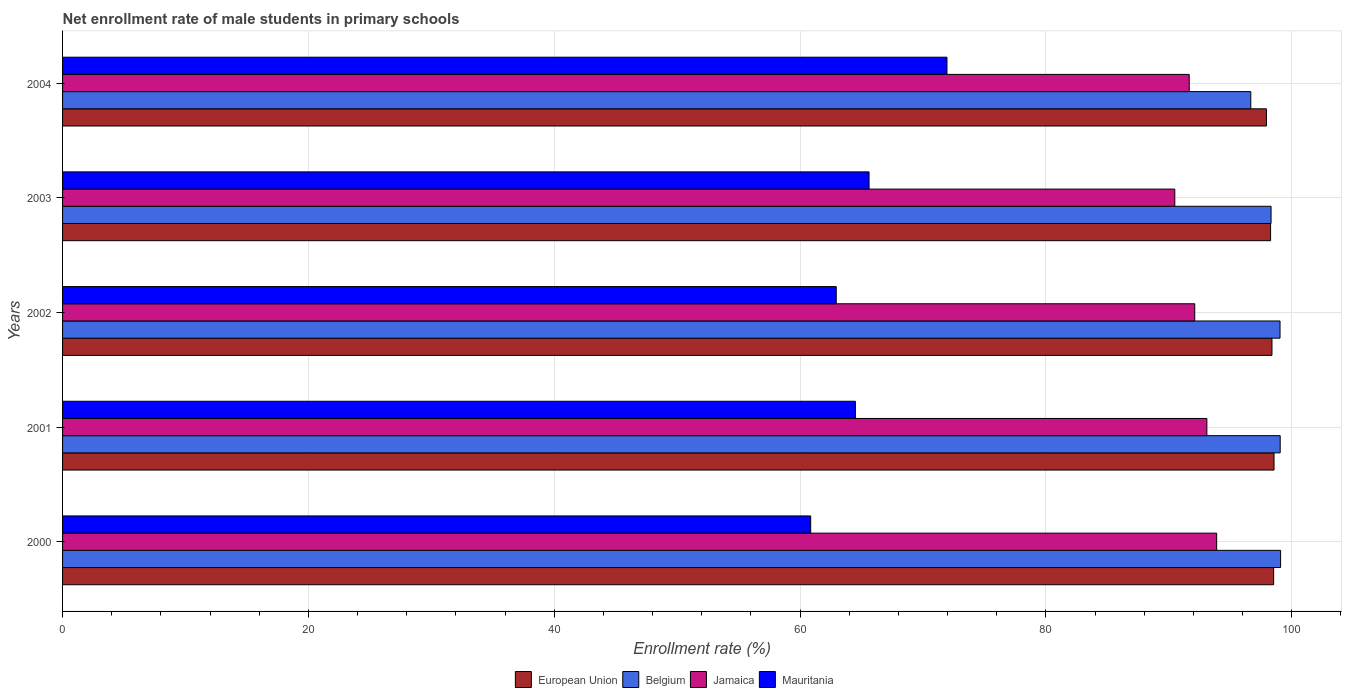How many different coloured bars are there?
Your answer should be very brief. 4. How many groups of bars are there?
Offer a very short reply. 5. Are the number of bars on each tick of the Y-axis equal?
Offer a very short reply. Yes. In how many cases, is the number of bars for a given year not equal to the number of legend labels?
Ensure brevity in your answer.  0. What is the net enrollment rate of male students in primary schools in Jamaica in 2003?
Your response must be concise. 90.48. Across all years, what is the maximum net enrollment rate of male students in primary schools in Mauritania?
Provide a succinct answer. 71.95. Across all years, what is the minimum net enrollment rate of male students in primary schools in Mauritania?
Offer a very short reply. 60.86. In which year was the net enrollment rate of male students in primary schools in European Union maximum?
Make the answer very short. 2001. In which year was the net enrollment rate of male students in primary schools in Mauritania minimum?
Offer a terse response. 2000. What is the total net enrollment rate of male students in primary schools in European Union in the graph?
Your response must be concise. 491.68. What is the difference between the net enrollment rate of male students in primary schools in European Union in 2000 and that in 2001?
Provide a succinct answer. -0.03. What is the difference between the net enrollment rate of male students in primary schools in Belgium in 2004 and the net enrollment rate of male students in primary schools in Jamaica in 2002?
Make the answer very short. 4.56. What is the average net enrollment rate of male students in primary schools in European Union per year?
Make the answer very short. 98.34. In the year 2000, what is the difference between the net enrollment rate of male students in primary schools in Mauritania and net enrollment rate of male students in primary schools in European Union?
Keep it short and to the point. -37.66. What is the ratio of the net enrollment rate of male students in primary schools in Jamaica in 2000 to that in 2003?
Give a very brief answer. 1.04. What is the difference between the highest and the second highest net enrollment rate of male students in primary schools in Mauritania?
Ensure brevity in your answer.  6.34. What is the difference between the highest and the lowest net enrollment rate of male students in primary schools in Belgium?
Keep it short and to the point. 2.42. Is the sum of the net enrollment rate of male students in primary schools in European Union in 2001 and 2003 greater than the maximum net enrollment rate of male students in primary schools in Belgium across all years?
Keep it short and to the point. Yes. What does the 3rd bar from the top in 2002 represents?
Offer a terse response. Belgium. What does the 3rd bar from the bottom in 2000 represents?
Your answer should be compact. Jamaica. How many years are there in the graph?
Keep it short and to the point. 5. What is the difference between two consecutive major ticks on the X-axis?
Give a very brief answer. 20. Are the values on the major ticks of X-axis written in scientific E-notation?
Offer a very short reply. No. Does the graph contain any zero values?
Provide a short and direct response. No. Where does the legend appear in the graph?
Offer a terse response. Bottom center. How are the legend labels stacked?
Your answer should be very brief. Horizontal. What is the title of the graph?
Keep it short and to the point. Net enrollment rate of male students in primary schools. Does "Russian Federation" appear as one of the legend labels in the graph?
Offer a terse response. No. What is the label or title of the X-axis?
Provide a succinct answer. Enrollment rate (%). What is the label or title of the Y-axis?
Your answer should be compact. Years. What is the Enrollment rate (%) in European Union in 2000?
Your answer should be very brief. 98.53. What is the Enrollment rate (%) in Belgium in 2000?
Offer a terse response. 99.09. What is the Enrollment rate (%) of Jamaica in 2000?
Provide a short and direct response. 93.89. What is the Enrollment rate (%) in Mauritania in 2000?
Offer a terse response. 60.86. What is the Enrollment rate (%) in European Union in 2001?
Your response must be concise. 98.56. What is the Enrollment rate (%) of Belgium in 2001?
Ensure brevity in your answer.  99.06. What is the Enrollment rate (%) in Jamaica in 2001?
Provide a succinct answer. 93.09. What is the Enrollment rate (%) in Mauritania in 2001?
Give a very brief answer. 64.5. What is the Enrollment rate (%) in European Union in 2002?
Make the answer very short. 98.39. What is the Enrollment rate (%) of Belgium in 2002?
Offer a terse response. 99.04. What is the Enrollment rate (%) in Jamaica in 2002?
Your answer should be very brief. 92.11. What is the Enrollment rate (%) in Mauritania in 2002?
Provide a short and direct response. 62.94. What is the Enrollment rate (%) of European Union in 2003?
Offer a terse response. 98.28. What is the Enrollment rate (%) in Belgium in 2003?
Give a very brief answer. 98.32. What is the Enrollment rate (%) in Jamaica in 2003?
Your answer should be compact. 90.48. What is the Enrollment rate (%) of Mauritania in 2003?
Provide a succinct answer. 65.61. What is the Enrollment rate (%) in European Union in 2004?
Give a very brief answer. 97.94. What is the Enrollment rate (%) of Belgium in 2004?
Keep it short and to the point. 96.67. What is the Enrollment rate (%) in Jamaica in 2004?
Give a very brief answer. 91.66. What is the Enrollment rate (%) of Mauritania in 2004?
Give a very brief answer. 71.95. Across all years, what is the maximum Enrollment rate (%) of European Union?
Offer a very short reply. 98.56. Across all years, what is the maximum Enrollment rate (%) in Belgium?
Provide a succinct answer. 99.09. Across all years, what is the maximum Enrollment rate (%) of Jamaica?
Give a very brief answer. 93.89. Across all years, what is the maximum Enrollment rate (%) of Mauritania?
Give a very brief answer. 71.95. Across all years, what is the minimum Enrollment rate (%) of European Union?
Give a very brief answer. 97.94. Across all years, what is the minimum Enrollment rate (%) in Belgium?
Give a very brief answer. 96.67. Across all years, what is the minimum Enrollment rate (%) of Jamaica?
Ensure brevity in your answer.  90.48. Across all years, what is the minimum Enrollment rate (%) in Mauritania?
Provide a succinct answer. 60.86. What is the total Enrollment rate (%) of European Union in the graph?
Offer a very short reply. 491.68. What is the total Enrollment rate (%) of Belgium in the graph?
Offer a terse response. 492.17. What is the total Enrollment rate (%) of Jamaica in the graph?
Provide a succinct answer. 461.23. What is the total Enrollment rate (%) in Mauritania in the graph?
Offer a very short reply. 325.86. What is the difference between the Enrollment rate (%) in European Union in 2000 and that in 2001?
Give a very brief answer. -0.03. What is the difference between the Enrollment rate (%) of Jamaica in 2000 and that in 2001?
Offer a terse response. 0.8. What is the difference between the Enrollment rate (%) in Mauritania in 2000 and that in 2001?
Your answer should be very brief. -3.64. What is the difference between the Enrollment rate (%) in European Union in 2000 and that in 2002?
Your response must be concise. 0.14. What is the difference between the Enrollment rate (%) in Belgium in 2000 and that in 2002?
Provide a succinct answer. 0.05. What is the difference between the Enrollment rate (%) in Jamaica in 2000 and that in 2002?
Give a very brief answer. 1.78. What is the difference between the Enrollment rate (%) of Mauritania in 2000 and that in 2002?
Your answer should be compact. -2.08. What is the difference between the Enrollment rate (%) of European Union in 2000 and that in 2003?
Provide a succinct answer. 0.25. What is the difference between the Enrollment rate (%) of Belgium in 2000 and that in 2003?
Offer a very short reply. 0.78. What is the difference between the Enrollment rate (%) of Jamaica in 2000 and that in 2003?
Ensure brevity in your answer.  3.41. What is the difference between the Enrollment rate (%) in Mauritania in 2000 and that in 2003?
Ensure brevity in your answer.  -4.75. What is the difference between the Enrollment rate (%) of European Union in 2000 and that in 2004?
Your response must be concise. 0.59. What is the difference between the Enrollment rate (%) in Belgium in 2000 and that in 2004?
Offer a very short reply. 2.42. What is the difference between the Enrollment rate (%) of Jamaica in 2000 and that in 2004?
Your answer should be compact. 2.23. What is the difference between the Enrollment rate (%) in Mauritania in 2000 and that in 2004?
Offer a very short reply. -11.09. What is the difference between the Enrollment rate (%) in European Union in 2001 and that in 2002?
Give a very brief answer. 0.17. What is the difference between the Enrollment rate (%) of Belgium in 2001 and that in 2002?
Offer a terse response. 0.01. What is the difference between the Enrollment rate (%) in Jamaica in 2001 and that in 2002?
Give a very brief answer. 0.99. What is the difference between the Enrollment rate (%) of Mauritania in 2001 and that in 2002?
Offer a terse response. 1.56. What is the difference between the Enrollment rate (%) in European Union in 2001 and that in 2003?
Ensure brevity in your answer.  0.28. What is the difference between the Enrollment rate (%) of Belgium in 2001 and that in 2003?
Provide a succinct answer. 0.74. What is the difference between the Enrollment rate (%) in Jamaica in 2001 and that in 2003?
Provide a succinct answer. 2.61. What is the difference between the Enrollment rate (%) in Mauritania in 2001 and that in 2003?
Provide a succinct answer. -1.11. What is the difference between the Enrollment rate (%) in European Union in 2001 and that in 2004?
Give a very brief answer. 0.62. What is the difference between the Enrollment rate (%) in Belgium in 2001 and that in 2004?
Keep it short and to the point. 2.39. What is the difference between the Enrollment rate (%) in Jamaica in 2001 and that in 2004?
Your answer should be very brief. 1.43. What is the difference between the Enrollment rate (%) in Mauritania in 2001 and that in 2004?
Keep it short and to the point. -7.45. What is the difference between the Enrollment rate (%) of European Union in 2002 and that in 2003?
Give a very brief answer. 0.11. What is the difference between the Enrollment rate (%) in Belgium in 2002 and that in 2003?
Your answer should be very brief. 0.73. What is the difference between the Enrollment rate (%) of Jamaica in 2002 and that in 2003?
Offer a terse response. 1.62. What is the difference between the Enrollment rate (%) of Mauritania in 2002 and that in 2003?
Your response must be concise. -2.67. What is the difference between the Enrollment rate (%) in European Union in 2002 and that in 2004?
Your answer should be very brief. 0.45. What is the difference between the Enrollment rate (%) of Belgium in 2002 and that in 2004?
Your response must be concise. 2.38. What is the difference between the Enrollment rate (%) in Jamaica in 2002 and that in 2004?
Give a very brief answer. 0.45. What is the difference between the Enrollment rate (%) of Mauritania in 2002 and that in 2004?
Your answer should be compact. -9.01. What is the difference between the Enrollment rate (%) of European Union in 2003 and that in 2004?
Offer a terse response. 0.34. What is the difference between the Enrollment rate (%) in Belgium in 2003 and that in 2004?
Offer a terse response. 1.65. What is the difference between the Enrollment rate (%) in Jamaica in 2003 and that in 2004?
Your answer should be very brief. -1.17. What is the difference between the Enrollment rate (%) of Mauritania in 2003 and that in 2004?
Provide a succinct answer. -6.34. What is the difference between the Enrollment rate (%) of European Union in 2000 and the Enrollment rate (%) of Belgium in 2001?
Give a very brief answer. -0.53. What is the difference between the Enrollment rate (%) of European Union in 2000 and the Enrollment rate (%) of Jamaica in 2001?
Keep it short and to the point. 5.43. What is the difference between the Enrollment rate (%) of European Union in 2000 and the Enrollment rate (%) of Mauritania in 2001?
Offer a terse response. 34.02. What is the difference between the Enrollment rate (%) in Belgium in 2000 and the Enrollment rate (%) in Jamaica in 2001?
Offer a terse response. 6. What is the difference between the Enrollment rate (%) of Belgium in 2000 and the Enrollment rate (%) of Mauritania in 2001?
Provide a succinct answer. 34.59. What is the difference between the Enrollment rate (%) of Jamaica in 2000 and the Enrollment rate (%) of Mauritania in 2001?
Offer a terse response. 29.39. What is the difference between the Enrollment rate (%) in European Union in 2000 and the Enrollment rate (%) in Belgium in 2002?
Make the answer very short. -0.52. What is the difference between the Enrollment rate (%) of European Union in 2000 and the Enrollment rate (%) of Jamaica in 2002?
Your answer should be compact. 6.42. What is the difference between the Enrollment rate (%) in European Union in 2000 and the Enrollment rate (%) in Mauritania in 2002?
Keep it short and to the point. 35.58. What is the difference between the Enrollment rate (%) of Belgium in 2000 and the Enrollment rate (%) of Jamaica in 2002?
Ensure brevity in your answer.  6.98. What is the difference between the Enrollment rate (%) of Belgium in 2000 and the Enrollment rate (%) of Mauritania in 2002?
Your answer should be very brief. 36.15. What is the difference between the Enrollment rate (%) in Jamaica in 2000 and the Enrollment rate (%) in Mauritania in 2002?
Provide a short and direct response. 30.95. What is the difference between the Enrollment rate (%) of European Union in 2000 and the Enrollment rate (%) of Belgium in 2003?
Make the answer very short. 0.21. What is the difference between the Enrollment rate (%) of European Union in 2000 and the Enrollment rate (%) of Jamaica in 2003?
Ensure brevity in your answer.  8.04. What is the difference between the Enrollment rate (%) of European Union in 2000 and the Enrollment rate (%) of Mauritania in 2003?
Provide a succinct answer. 32.91. What is the difference between the Enrollment rate (%) in Belgium in 2000 and the Enrollment rate (%) in Jamaica in 2003?
Your answer should be very brief. 8.61. What is the difference between the Enrollment rate (%) of Belgium in 2000 and the Enrollment rate (%) of Mauritania in 2003?
Provide a succinct answer. 33.48. What is the difference between the Enrollment rate (%) in Jamaica in 2000 and the Enrollment rate (%) in Mauritania in 2003?
Your answer should be compact. 28.28. What is the difference between the Enrollment rate (%) of European Union in 2000 and the Enrollment rate (%) of Belgium in 2004?
Give a very brief answer. 1.86. What is the difference between the Enrollment rate (%) in European Union in 2000 and the Enrollment rate (%) in Jamaica in 2004?
Offer a terse response. 6.87. What is the difference between the Enrollment rate (%) of European Union in 2000 and the Enrollment rate (%) of Mauritania in 2004?
Offer a terse response. 26.58. What is the difference between the Enrollment rate (%) of Belgium in 2000 and the Enrollment rate (%) of Jamaica in 2004?
Provide a succinct answer. 7.43. What is the difference between the Enrollment rate (%) in Belgium in 2000 and the Enrollment rate (%) in Mauritania in 2004?
Your answer should be very brief. 27.14. What is the difference between the Enrollment rate (%) in Jamaica in 2000 and the Enrollment rate (%) in Mauritania in 2004?
Provide a short and direct response. 21.94. What is the difference between the Enrollment rate (%) in European Union in 2001 and the Enrollment rate (%) in Belgium in 2002?
Keep it short and to the point. -0.49. What is the difference between the Enrollment rate (%) in European Union in 2001 and the Enrollment rate (%) in Jamaica in 2002?
Offer a terse response. 6.45. What is the difference between the Enrollment rate (%) in European Union in 2001 and the Enrollment rate (%) in Mauritania in 2002?
Provide a short and direct response. 35.61. What is the difference between the Enrollment rate (%) in Belgium in 2001 and the Enrollment rate (%) in Jamaica in 2002?
Your answer should be very brief. 6.95. What is the difference between the Enrollment rate (%) of Belgium in 2001 and the Enrollment rate (%) of Mauritania in 2002?
Make the answer very short. 36.12. What is the difference between the Enrollment rate (%) in Jamaica in 2001 and the Enrollment rate (%) in Mauritania in 2002?
Provide a short and direct response. 30.15. What is the difference between the Enrollment rate (%) in European Union in 2001 and the Enrollment rate (%) in Belgium in 2003?
Offer a terse response. 0.24. What is the difference between the Enrollment rate (%) in European Union in 2001 and the Enrollment rate (%) in Jamaica in 2003?
Provide a short and direct response. 8.07. What is the difference between the Enrollment rate (%) in European Union in 2001 and the Enrollment rate (%) in Mauritania in 2003?
Ensure brevity in your answer.  32.95. What is the difference between the Enrollment rate (%) in Belgium in 2001 and the Enrollment rate (%) in Jamaica in 2003?
Keep it short and to the point. 8.57. What is the difference between the Enrollment rate (%) in Belgium in 2001 and the Enrollment rate (%) in Mauritania in 2003?
Provide a short and direct response. 33.45. What is the difference between the Enrollment rate (%) in Jamaica in 2001 and the Enrollment rate (%) in Mauritania in 2003?
Provide a short and direct response. 27.48. What is the difference between the Enrollment rate (%) of European Union in 2001 and the Enrollment rate (%) of Belgium in 2004?
Provide a succinct answer. 1.89. What is the difference between the Enrollment rate (%) of European Union in 2001 and the Enrollment rate (%) of Jamaica in 2004?
Offer a terse response. 6.9. What is the difference between the Enrollment rate (%) of European Union in 2001 and the Enrollment rate (%) of Mauritania in 2004?
Make the answer very short. 26.61. What is the difference between the Enrollment rate (%) of Belgium in 2001 and the Enrollment rate (%) of Jamaica in 2004?
Ensure brevity in your answer.  7.4. What is the difference between the Enrollment rate (%) of Belgium in 2001 and the Enrollment rate (%) of Mauritania in 2004?
Offer a very short reply. 27.11. What is the difference between the Enrollment rate (%) in Jamaica in 2001 and the Enrollment rate (%) in Mauritania in 2004?
Ensure brevity in your answer.  21.14. What is the difference between the Enrollment rate (%) in European Union in 2002 and the Enrollment rate (%) in Belgium in 2003?
Give a very brief answer. 0.07. What is the difference between the Enrollment rate (%) of European Union in 2002 and the Enrollment rate (%) of Jamaica in 2003?
Keep it short and to the point. 7.91. What is the difference between the Enrollment rate (%) of European Union in 2002 and the Enrollment rate (%) of Mauritania in 2003?
Provide a short and direct response. 32.78. What is the difference between the Enrollment rate (%) in Belgium in 2002 and the Enrollment rate (%) in Jamaica in 2003?
Give a very brief answer. 8.56. What is the difference between the Enrollment rate (%) of Belgium in 2002 and the Enrollment rate (%) of Mauritania in 2003?
Offer a terse response. 33.43. What is the difference between the Enrollment rate (%) in Jamaica in 2002 and the Enrollment rate (%) in Mauritania in 2003?
Make the answer very short. 26.5. What is the difference between the Enrollment rate (%) in European Union in 2002 and the Enrollment rate (%) in Belgium in 2004?
Your response must be concise. 1.72. What is the difference between the Enrollment rate (%) in European Union in 2002 and the Enrollment rate (%) in Jamaica in 2004?
Your answer should be very brief. 6.73. What is the difference between the Enrollment rate (%) of European Union in 2002 and the Enrollment rate (%) of Mauritania in 2004?
Your answer should be compact. 26.44. What is the difference between the Enrollment rate (%) in Belgium in 2002 and the Enrollment rate (%) in Jamaica in 2004?
Offer a very short reply. 7.39. What is the difference between the Enrollment rate (%) of Belgium in 2002 and the Enrollment rate (%) of Mauritania in 2004?
Give a very brief answer. 27.1. What is the difference between the Enrollment rate (%) of Jamaica in 2002 and the Enrollment rate (%) of Mauritania in 2004?
Ensure brevity in your answer.  20.16. What is the difference between the Enrollment rate (%) in European Union in 2003 and the Enrollment rate (%) in Belgium in 2004?
Make the answer very short. 1.61. What is the difference between the Enrollment rate (%) of European Union in 2003 and the Enrollment rate (%) of Jamaica in 2004?
Your response must be concise. 6.62. What is the difference between the Enrollment rate (%) in European Union in 2003 and the Enrollment rate (%) in Mauritania in 2004?
Offer a very short reply. 26.33. What is the difference between the Enrollment rate (%) of Belgium in 2003 and the Enrollment rate (%) of Jamaica in 2004?
Offer a terse response. 6.66. What is the difference between the Enrollment rate (%) in Belgium in 2003 and the Enrollment rate (%) in Mauritania in 2004?
Make the answer very short. 26.37. What is the difference between the Enrollment rate (%) of Jamaica in 2003 and the Enrollment rate (%) of Mauritania in 2004?
Your answer should be compact. 18.53. What is the average Enrollment rate (%) in European Union per year?
Make the answer very short. 98.34. What is the average Enrollment rate (%) in Belgium per year?
Offer a very short reply. 98.43. What is the average Enrollment rate (%) of Jamaica per year?
Your response must be concise. 92.25. What is the average Enrollment rate (%) of Mauritania per year?
Ensure brevity in your answer.  65.17. In the year 2000, what is the difference between the Enrollment rate (%) in European Union and Enrollment rate (%) in Belgium?
Ensure brevity in your answer.  -0.57. In the year 2000, what is the difference between the Enrollment rate (%) of European Union and Enrollment rate (%) of Jamaica?
Provide a succinct answer. 4.63. In the year 2000, what is the difference between the Enrollment rate (%) in European Union and Enrollment rate (%) in Mauritania?
Your response must be concise. 37.66. In the year 2000, what is the difference between the Enrollment rate (%) of Belgium and Enrollment rate (%) of Jamaica?
Offer a terse response. 5.2. In the year 2000, what is the difference between the Enrollment rate (%) of Belgium and Enrollment rate (%) of Mauritania?
Your response must be concise. 38.23. In the year 2000, what is the difference between the Enrollment rate (%) in Jamaica and Enrollment rate (%) in Mauritania?
Offer a very short reply. 33.03. In the year 2001, what is the difference between the Enrollment rate (%) in European Union and Enrollment rate (%) in Belgium?
Keep it short and to the point. -0.5. In the year 2001, what is the difference between the Enrollment rate (%) of European Union and Enrollment rate (%) of Jamaica?
Offer a terse response. 5.46. In the year 2001, what is the difference between the Enrollment rate (%) of European Union and Enrollment rate (%) of Mauritania?
Ensure brevity in your answer.  34.06. In the year 2001, what is the difference between the Enrollment rate (%) of Belgium and Enrollment rate (%) of Jamaica?
Ensure brevity in your answer.  5.96. In the year 2001, what is the difference between the Enrollment rate (%) of Belgium and Enrollment rate (%) of Mauritania?
Ensure brevity in your answer.  34.56. In the year 2001, what is the difference between the Enrollment rate (%) in Jamaica and Enrollment rate (%) in Mauritania?
Give a very brief answer. 28.59. In the year 2002, what is the difference between the Enrollment rate (%) in European Union and Enrollment rate (%) in Belgium?
Provide a short and direct response. -0.66. In the year 2002, what is the difference between the Enrollment rate (%) of European Union and Enrollment rate (%) of Jamaica?
Offer a very short reply. 6.28. In the year 2002, what is the difference between the Enrollment rate (%) in European Union and Enrollment rate (%) in Mauritania?
Offer a terse response. 35.45. In the year 2002, what is the difference between the Enrollment rate (%) of Belgium and Enrollment rate (%) of Jamaica?
Keep it short and to the point. 6.94. In the year 2002, what is the difference between the Enrollment rate (%) in Belgium and Enrollment rate (%) in Mauritania?
Offer a very short reply. 36.1. In the year 2002, what is the difference between the Enrollment rate (%) of Jamaica and Enrollment rate (%) of Mauritania?
Give a very brief answer. 29.17. In the year 2003, what is the difference between the Enrollment rate (%) in European Union and Enrollment rate (%) in Belgium?
Keep it short and to the point. -0.04. In the year 2003, what is the difference between the Enrollment rate (%) of European Union and Enrollment rate (%) of Jamaica?
Offer a terse response. 7.79. In the year 2003, what is the difference between the Enrollment rate (%) of European Union and Enrollment rate (%) of Mauritania?
Keep it short and to the point. 32.66. In the year 2003, what is the difference between the Enrollment rate (%) in Belgium and Enrollment rate (%) in Jamaica?
Keep it short and to the point. 7.83. In the year 2003, what is the difference between the Enrollment rate (%) of Belgium and Enrollment rate (%) of Mauritania?
Provide a succinct answer. 32.7. In the year 2003, what is the difference between the Enrollment rate (%) in Jamaica and Enrollment rate (%) in Mauritania?
Provide a succinct answer. 24.87. In the year 2004, what is the difference between the Enrollment rate (%) of European Union and Enrollment rate (%) of Belgium?
Make the answer very short. 1.27. In the year 2004, what is the difference between the Enrollment rate (%) in European Union and Enrollment rate (%) in Jamaica?
Make the answer very short. 6.28. In the year 2004, what is the difference between the Enrollment rate (%) of European Union and Enrollment rate (%) of Mauritania?
Give a very brief answer. 25.99. In the year 2004, what is the difference between the Enrollment rate (%) in Belgium and Enrollment rate (%) in Jamaica?
Give a very brief answer. 5.01. In the year 2004, what is the difference between the Enrollment rate (%) in Belgium and Enrollment rate (%) in Mauritania?
Provide a succinct answer. 24.72. In the year 2004, what is the difference between the Enrollment rate (%) in Jamaica and Enrollment rate (%) in Mauritania?
Offer a very short reply. 19.71. What is the ratio of the Enrollment rate (%) in Jamaica in 2000 to that in 2001?
Give a very brief answer. 1.01. What is the ratio of the Enrollment rate (%) in Mauritania in 2000 to that in 2001?
Your answer should be very brief. 0.94. What is the ratio of the Enrollment rate (%) in European Union in 2000 to that in 2002?
Offer a terse response. 1. What is the ratio of the Enrollment rate (%) in Belgium in 2000 to that in 2002?
Offer a very short reply. 1. What is the ratio of the Enrollment rate (%) in Jamaica in 2000 to that in 2002?
Offer a very short reply. 1.02. What is the ratio of the Enrollment rate (%) in Mauritania in 2000 to that in 2002?
Provide a short and direct response. 0.97. What is the ratio of the Enrollment rate (%) in European Union in 2000 to that in 2003?
Offer a very short reply. 1. What is the ratio of the Enrollment rate (%) of Belgium in 2000 to that in 2003?
Keep it short and to the point. 1.01. What is the ratio of the Enrollment rate (%) in Jamaica in 2000 to that in 2003?
Provide a succinct answer. 1.04. What is the ratio of the Enrollment rate (%) in Mauritania in 2000 to that in 2003?
Provide a succinct answer. 0.93. What is the ratio of the Enrollment rate (%) in European Union in 2000 to that in 2004?
Give a very brief answer. 1.01. What is the ratio of the Enrollment rate (%) of Belgium in 2000 to that in 2004?
Your response must be concise. 1.03. What is the ratio of the Enrollment rate (%) of Jamaica in 2000 to that in 2004?
Your response must be concise. 1.02. What is the ratio of the Enrollment rate (%) of Mauritania in 2000 to that in 2004?
Keep it short and to the point. 0.85. What is the ratio of the Enrollment rate (%) of Jamaica in 2001 to that in 2002?
Provide a short and direct response. 1.01. What is the ratio of the Enrollment rate (%) of Mauritania in 2001 to that in 2002?
Offer a terse response. 1.02. What is the ratio of the Enrollment rate (%) in European Union in 2001 to that in 2003?
Give a very brief answer. 1. What is the ratio of the Enrollment rate (%) of Belgium in 2001 to that in 2003?
Your answer should be compact. 1.01. What is the ratio of the Enrollment rate (%) in Jamaica in 2001 to that in 2003?
Offer a very short reply. 1.03. What is the ratio of the Enrollment rate (%) of Mauritania in 2001 to that in 2003?
Offer a terse response. 0.98. What is the ratio of the Enrollment rate (%) in European Union in 2001 to that in 2004?
Offer a terse response. 1.01. What is the ratio of the Enrollment rate (%) of Belgium in 2001 to that in 2004?
Provide a succinct answer. 1.02. What is the ratio of the Enrollment rate (%) of Jamaica in 2001 to that in 2004?
Offer a very short reply. 1.02. What is the ratio of the Enrollment rate (%) of Mauritania in 2001 to that in 2004?
Provide a short and direct response. 0.9. What is the ratio of the Enrollment rate (%) in European Union in 2002 to that in 2003?
Make the answer very short. 1. What is the ratio of the Enrollment rate (%) of Belgium in 2002 to that in 2003?
Offer a very short reply. 1.01. What is the ratio of the Enrollment rate (%) in Jamaica in 2002 to that in 2003?
Your response must be concise. 1.02. What is the ratio of the Enrollment rate (%) of Mauritania in 2002 to that in 2003?
Give a very brief answer. 0.96. What is the ratio of the Enrollment rate (%) of Belgium in 2002 to that in 2004?
Provide a short and direct response. 1.02. What is the ratio of the Enrollment rate (%) of Jamaica in 2002 to that in 2004?
Offer a very short reply. 1. What is the ratio of the Enrollment rate (%) of Mauritania in 2002 to that in 2004?
Keep it short and to the point. 0.87. What is the ratio of the Enrollment rate (%) of Belgium in 2003 to that in 2004?
Your response must be concise. 1.02. What is the ratio of the Enrollment rate (%) of Jamaica in 2003 to that in 2004?
Provide a short and direct response. 0.99. What is the ratio of the Enrollment rate (%) of Mauritania in 2003 to that in 2004?
Your answer should be compact. 0.91. What is the difference between the highest and the second highest Enrollment rate (%) of European Union?
Your answer should be compact. 0.03. What is the difference between the highest and the second highest Enrollment rate (%) in Jamaica?
Offer a terse response. 0.8. What is the difference between the highest and the second highest Enrollment rate (%) in Mauritania?
Keep it short and to the point. 6.34. What is the difference between the highest and the lowest Enrollment rate (%) of European Union?
Keep it short and to the point. 0.62. What is the difference between the highest and the lowest Enrollment rate (%) of Belgium?
Offer a very short reply. 2.42. What is the difference between the highest and the lowest Enrollment rate (%) of Jamaica?
Give a very brief answer. 3.41. What is the difference between the highest and the lowest Enrollment rate (%) in Mauritania?
Your answer should be very brief. 11.09. 